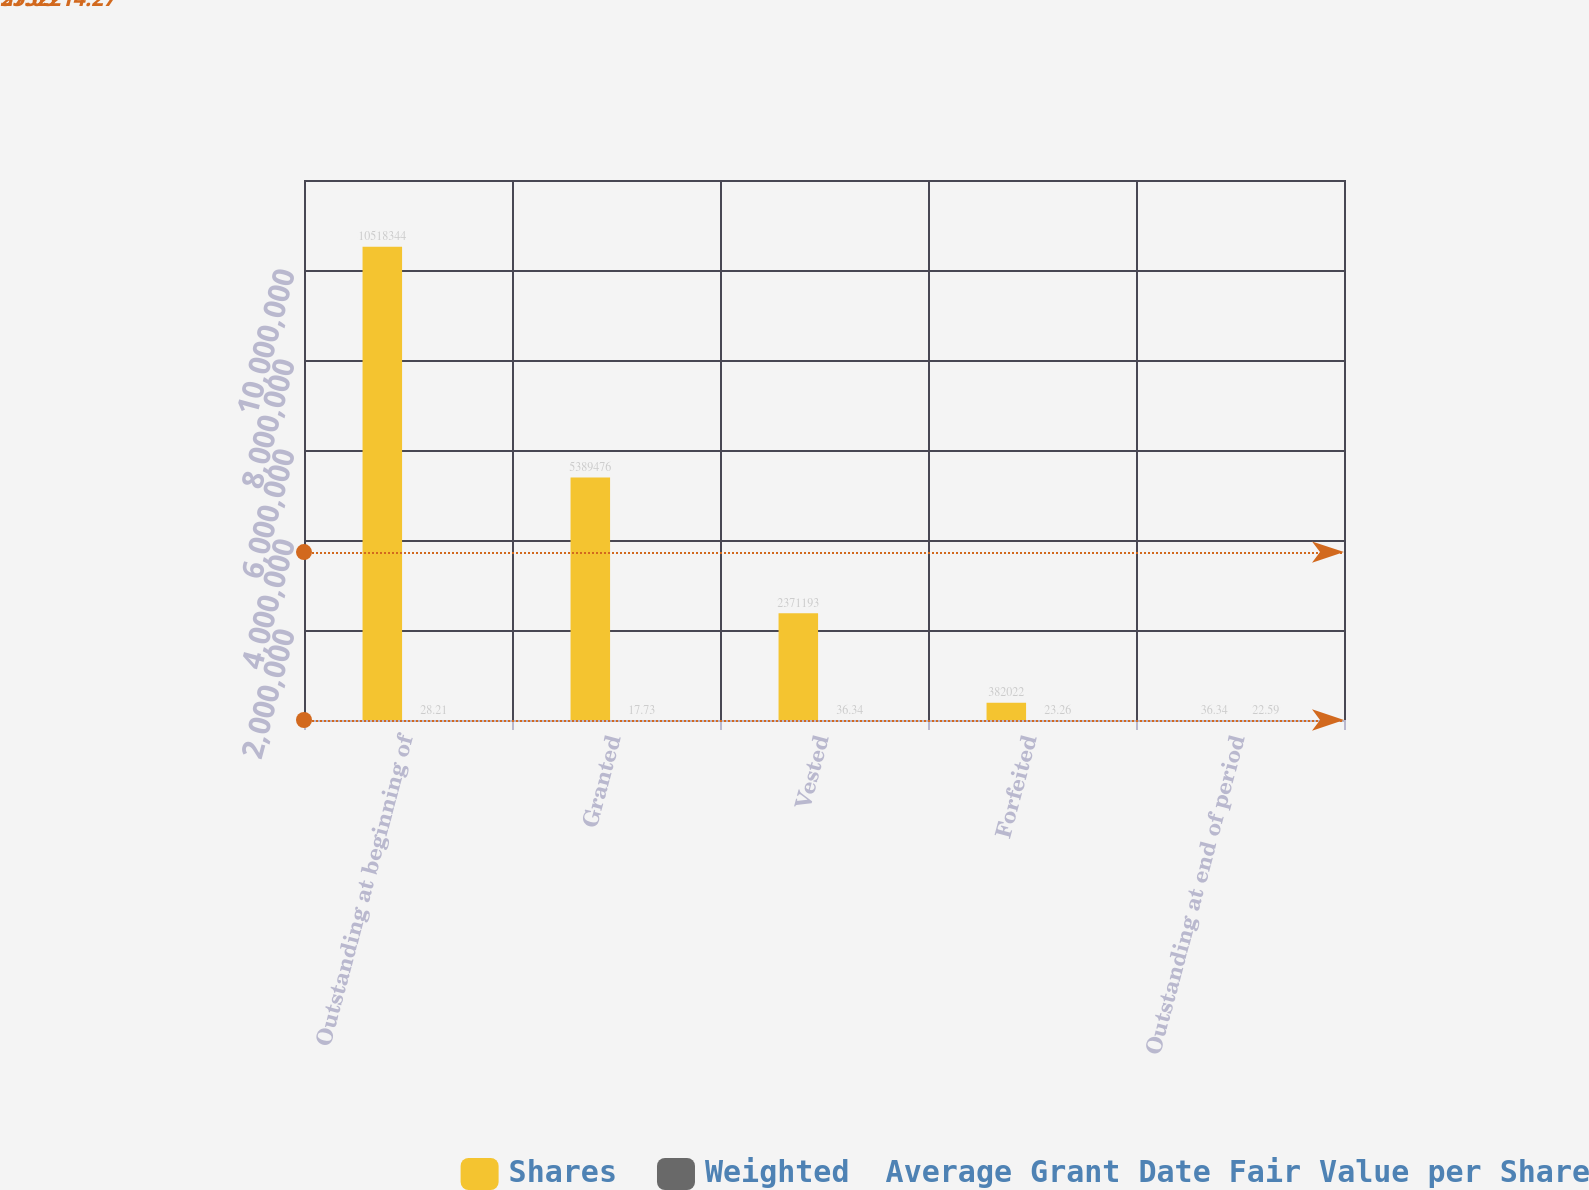<chart> <loc_0><loc_0><loc_500><loc_500><stacked_bar_chart><ecel><fcel>Outstanding at beginning of<fcel>Granted<fcel>Vested<fcel>Forfeited<fcel>Outstanding at end of period<nl><fcel>Shares<fcel>1.05183e+07<fcel>5.38948e+06<fcel>2.37119e+06<fcel>382022<fcel>36.34<nl><fcel>Weighted  Average Grant Date Fair Value per Share<fcel>28.21<fcel>17.73<fcel>36.34<fcel>23.26<fcel>22.59<nl></chart> 